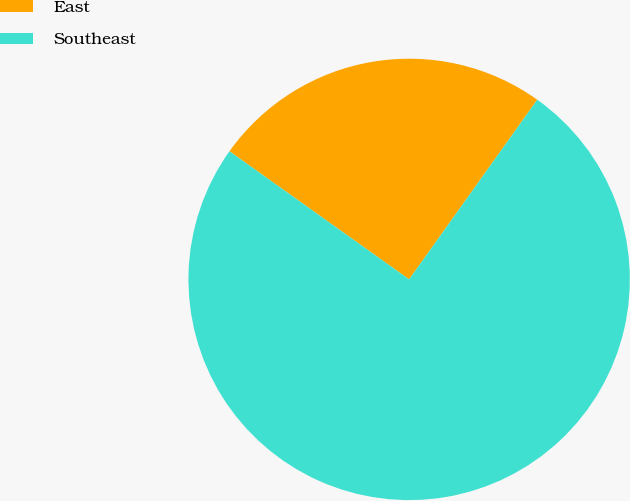Convert chart to OTSL. <chart><loc_0><loc_0><loc_500><loc_500><pie_chart><fcel>East<fcel>Southeast<nl><fcel>25.0%<fcel>75.0%<nl></chart> 